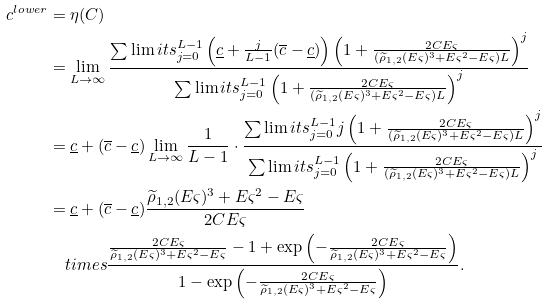Convert formula to latex. <formula><loc_0><loc_0><loc_500><loc_500>c ^ { l o w e r } & = \eta ( C ) \\ & = \lim _ { L \to \infty } \frac { \sum \lim i t s _ { j = 0 } ^ { L - 1 } \left ( \underline { c } + \frac { j } { L - 1 } ( \overline { c } - \underline { c } ) \right ) \left ( 1 + \frac { 2 C E \varsigma } { ( \widetilde { \rho } _ { 1 , 2 } ( E \varsigma ) ^ { 3 } + E \varsigma ^ { 2 } - E \varsigma ) L } \right ) ^ { j } } { \sum \lim i t s _ { j = 0 } ^ { L - 1 } \left ( 1 + \frac { 2 C E \varsigma } { ( \widetilde { \rho } _ { 1 , 2 } ( E \varsigma ) ^ { 3 } + E \varsigma ^ { 2 } - E \varsigma ) L } \right ) ^ { j } } \\ & = \underline { c } + ( \overline { c } - \underline { c } ) \lim _ { L \to \infty } \frac { 1 } { L - 1 } \cdot \frac { \sum \lim i t s _ { j = 0 } ^ { L - 1 } j \left ( 1 + \frac { 2 C E \varsigma } { ( \widetilde { \rho } _ { 1 , 2 } ( E \varsigma ) ^ { 3 } + E \varsigma ^ { 2 } - E \varsigma ) L } \right ) ^ { j } } { \sum \lim i t s _ { j = 0 } ^ { L - 1 } \left ( 1 + \frac { 2 C E \varsigma } { ( \widetilde { \rho } _ { 1 , 2 } ( E \varsigma ) ^ { 3 } + E \varsigma ^ { 2 } - E \varsigma ) L } \right ) ^ { j } } \\ & = \underline { c } + ( \overline { c } - \underline { c } ) \frac { \widetilde { \rho } _ { 1 , 2 } ( E \varsigma ) ^ { 3 } + E \varsigma ^ { 2 } - E \varsigma } { 2 C E \varsigma } \\ & \quad t i m e s \frac { \frac { 2 C E \varsigma } { \widetilde { \rho } _ { 1 , 2 } ( E \varsigma ) ^ { 3 } + E \varsigma ^ { 2 } - E \varsigma } - 1 + \exp \left ( - \frac { 2 C E \varsigma } { \widetilde { \rho } _ { 1 , 2 } ( E \varsigma ) ^ { 3 } + E \varsigma ^ { 2 } - E \varsigma } \right ) } { 1 - \exp \left ( - \frac { 2 C E \varsigma } { \widetilde { \rho } _ { 1 , 2 } ( E \varsigma ) ^ { 3 } + E \varsigma ^ { 2 } - E \varsigma } \right ) } .</formula> 